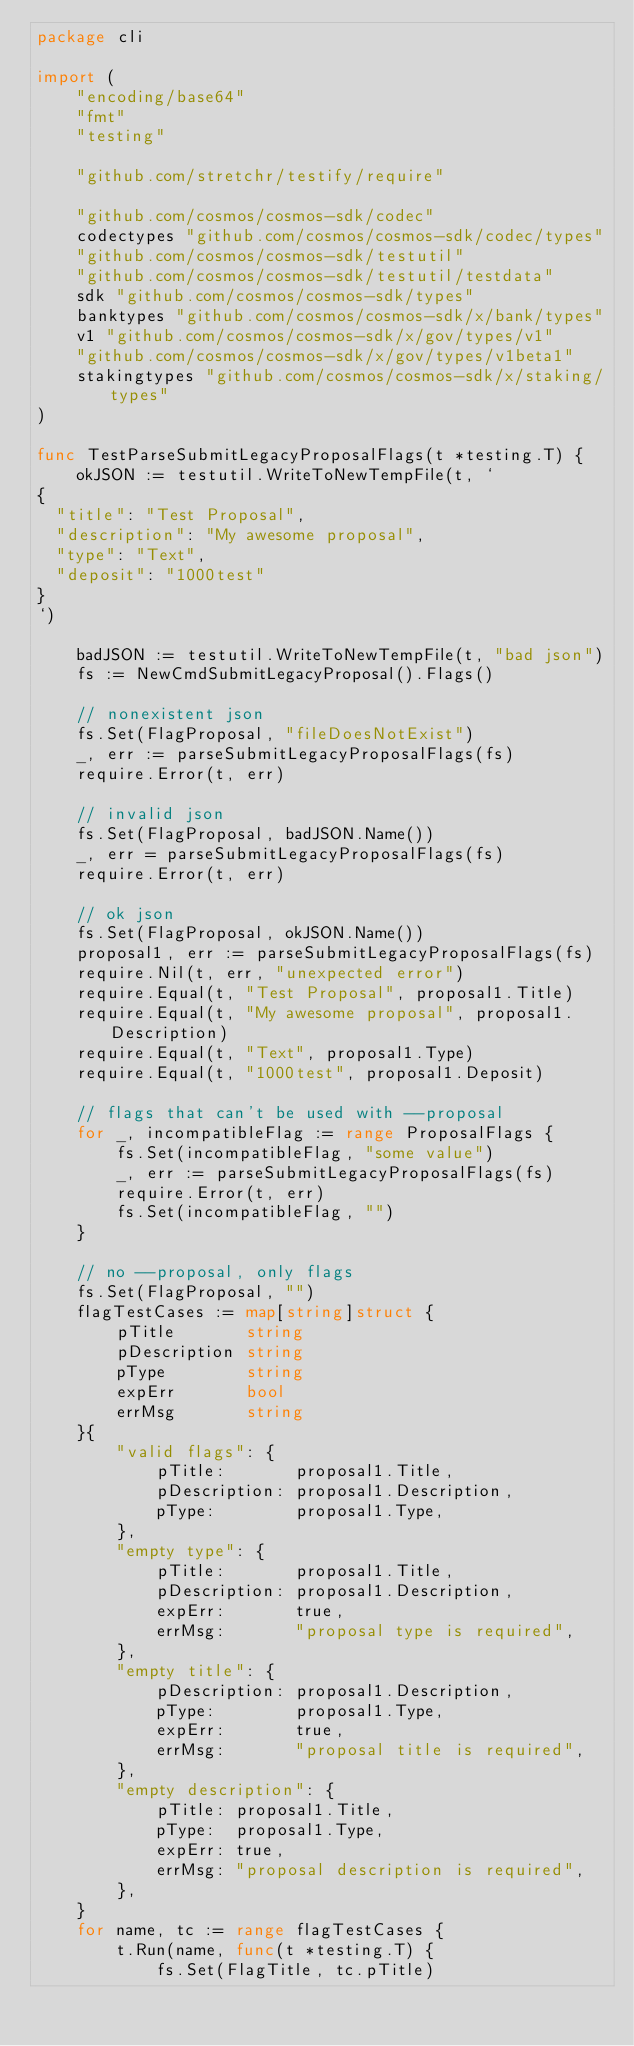<code> <loc_0><loc_0><loc_500><loc_500><_Go_>package cli

import (
	"encoding/base64"
	"fmt"
	"testing"

	"github.com/stretchr/testify/require"

	"github.com/cosmos/cosmos-sdk/codec"
	codectypes "github.com/cosmos/cosmos-sdk/codec/types"
	"github.com/cosmos/cosmos-sdk/testutil"
	"github.com/cosmos/cosmos-sdk/testutil/testdata"
	sdk "github.com/cosmos/cosmos-sdk/types"
	banktypes "github.com/cosmos/cosmos-sdk/x/bank/types"
	v1 "github.com/cosmos/cosmos-sdk/x/gov/types/v1"
	"github.com/cosmos/cosmos-sdk/x/gov/types/v1beta1"
	stakingtypes "github.com/cosmos/cosmos-sdk/x/staking/types"
)

func TestParseSubmitLegacyProposalFlags(t *testing.T) {
	okJSON := testutil.WriteToNewTempFile(t, `
{
  "title": "Test Proposal",
  "description": "My awesome proposal",
  "type": "Text",
  "deposit": "1000test"
}
`)

	badJSON := testutil.WriteToNewTempFile(t, "bad json")
	fs := NewCmdSubmitLegacyProposal().Flags()

	// nonexistent json
	fs.Set(FlagProposal, "fileDoesNotExist")
	_, err := parseSubmitLegacyProposalFlags(fs)
	require.Error(t, err)

	// invalid json
	fs.Set(FlagProposal, badJSON.Name())
	_, err = parseSubmitLegacyProposalFlags(fs)
	require.Error(t, err)

	// ok json
	fs.Set(FlagProposal, okJSON.Name())
	proposal1, err := parseSubmitLegacyProposalFlags(fs)
	require.Nil(t, err, "unexpected error")
	require.Equal(t, "Test Proposal", proposal1.Title)
	require.Equal(t, "My awesome proposal", proposal1.Description)
	require.Equal(t, "Text", proposal1.Type)
	require.Equal(t, "1000test", proposal1.Deposit)

	// flags that can't be used with --proposal
	for _, incompatibleFlag := range ProposalFlags {
		fs.Set(incompatibleFlag, "some value")
		_, err := parseSubmitLegacyProposalFlags(fs)
		require.Error(t, err)
		fs.Set(incompatibleFlag, "")
	}

	// no --proposal, only flags
	fs.Set(FlagProposal, "")
	flagTestCases := map[string]struct {
		pTitle       string
		pDescription string
		pType        string
		expErr       bool
		errMsg       string
	}{
		"valid flags": {
			pTitle:       proposal1.Title,
			pDescription: proposal1.Description,
			pType:        proposal1.Type,
		},
		"empty type": {
			pTitle:       proposal1.Title,
			pDescription: proposal1.Description,
			expErr:       true,
			errMsg:       "proposal type is required",
		},
		"empty title": {
			pDescription: proposal1.Description,
			pType:        proposal1.Type,
			expErr:       true,
			errMsg:       "proposal title is required",
		},
		"empty description": {
			pTitle: proposal1.Title,
			pType:  proposal1.Type,
			expErr: true,
			errMsg: "proposal description is required",
		},
	}
	for name, tc := range flagTestCases {
		t.Run(name, func(t *testing.T) {
			fs.Set(FlagTitle, tc.pTitle)</code> 